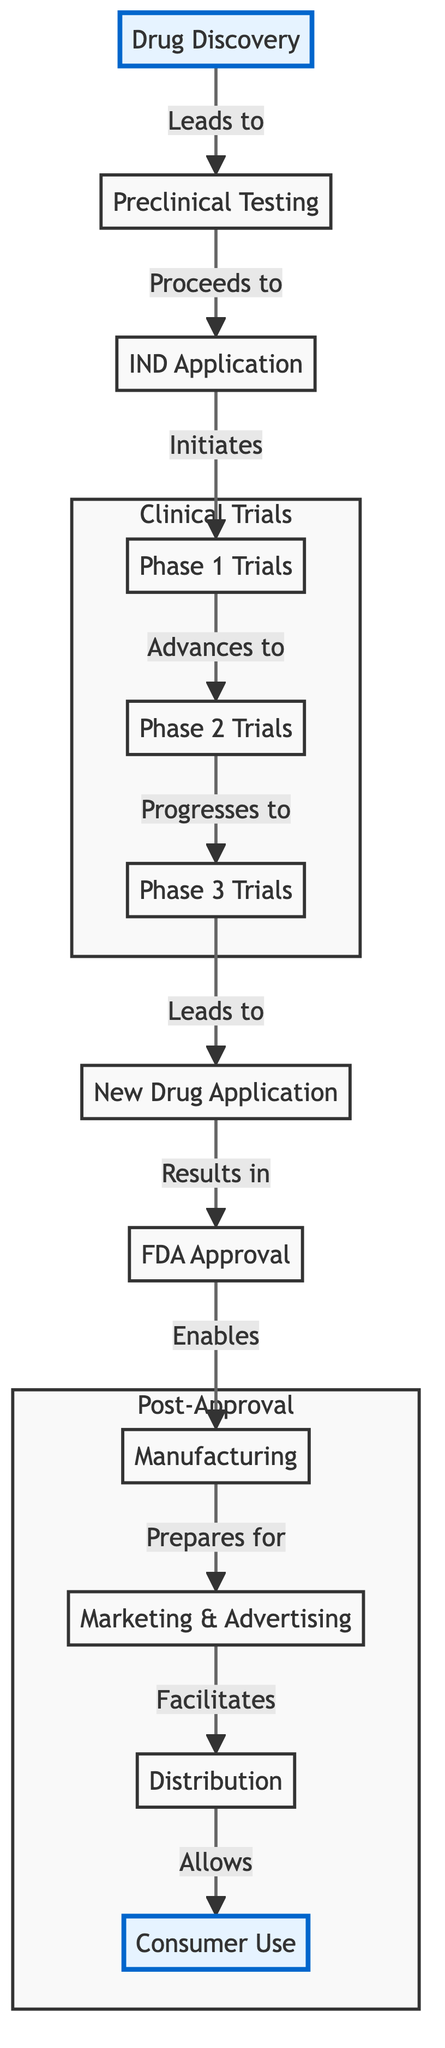What is the first step in the drug lifecycle? The diagram indicates that the first step in the drug lifecycle is "Drug Discovery." This is directly represented as the starting node in the flowchart.
Answer: Drug Discovery How many phases are there in clinical trials? The diagram shows three distinct phases within the Clinical Trials subgraph, which are Phase 1 Trials, Phase 2 Trials, and Phase 3 Trials.
Answer: 3 Which step follows the IND Application? According to the flow of the diagram, the step that immediately follows the IND Application node is Phase 1 Trials. This is shown by the arrow leading from the IND Application to the Phase 1 Trials.
Answer: Phase 1 Trials What enables manufacturing? The diagram illustrates that "FDA Approval" is the step that enables "Manufacturing," as indicated by the arrow pointing from FDA Approval to Manufacturing.
Answer: FDA Approval What step is associated with "Marketing & Advertising"? In examining the flowchart, "Marketing & Advertising" follows directly after "Manufacturing," indicating it is associated with this step. The relationship is clearly indicated by the arrow leading from Manufacturing to Marketing & Advertising.
Answer: Manufacturing What is the final step before consumer use? The last step that occurs before consumer use is "Distribution," as shown in the flowchart right before the node for Consumer Use. The arrow leads from Distribution to Consumer Use.
Answer: Distribution How does "Phase 2 Trials" relate to "Phase 3 Trials"? The relationship is sequential; "Phase 2 Trials" directly progresses to "Phase 3 Trials," as indicated by the arrow connecting these two nodes in the Clinical Trials subgraph.
Answer: Progresses to What occurs after the New Drug Application? Following the New Drug Application in the diagram, the next step is "FDA Approval," represented by an arrow that moves from the New Drug Application to FDA Approval.
Answer: FDA Approval How many nodes are part of the Post-Approval process? The Post-Approval section of the diagram includes four nodes: Manufacturing, Marketing & Advertising, Distribution, and Consumer Use. Therefore, there are four nodes in this subgraph.
Answer: 4 